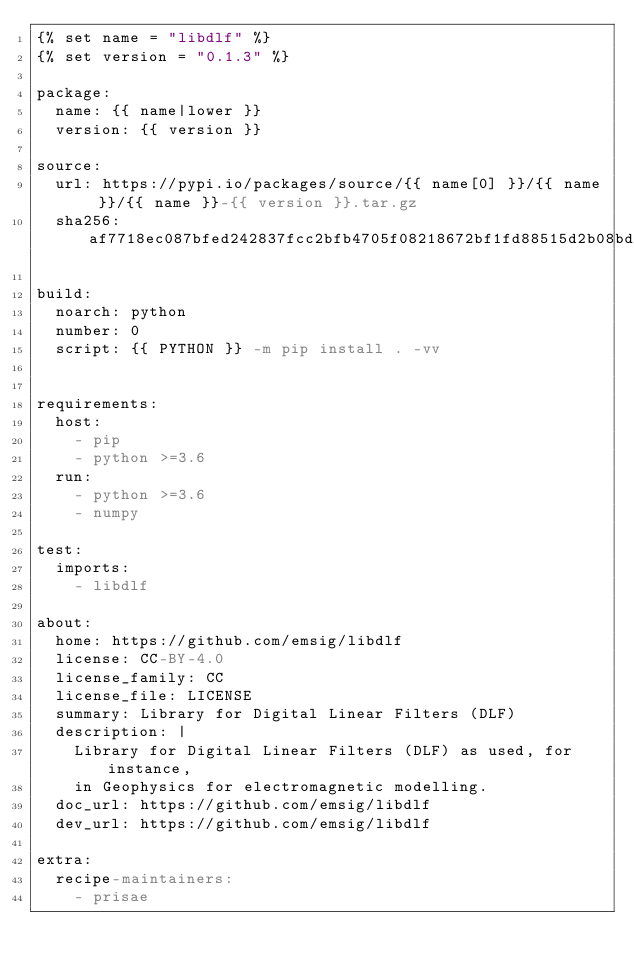Convert code to text. <code><loc_0><loc_0><loc_500><loc_500><_YAML_>{% set name = "libdlf" %}
{% set version = "0.1.3" %}

package:
  name: {{ name|lower }}
  version: {{ version }}

source:
  url: https://pypi.io/packages/source/{{ name[0] }}/{{ name }}/{{ name }}-{{ version }}.tar.gz
  sha256: af7718ec087bfed242837fcc2bfb4705f08218672bf1fd88515d2b08bd7ec300

build:
  noarch: python
  number: 0
  script: {{ PYTHON }} -m pip install . -vv


requirements:
  host:
    - pip
    - python >=3.6
  run:
    - python >=3.6
    - numpy

test:
  imports:
    - libdlf

about:
  home: https://github.com/emsig/libdlf
  license: CC-BY-4.0
  license_family: CC
  license_file: LICENSE
  summary: Library for Digital Linear Filters (DLF)
  description: |
    Library for Digital Linear Filters (DLF) as used, for instance,
    in Geophysics for electromagnetic modelling.
  doc_url: https://github.com/emsig/libdlf
  dev_url: https://github.com/emsig/libdlf

extra:
  recipe-maintainers:
    - prisae
</code> 